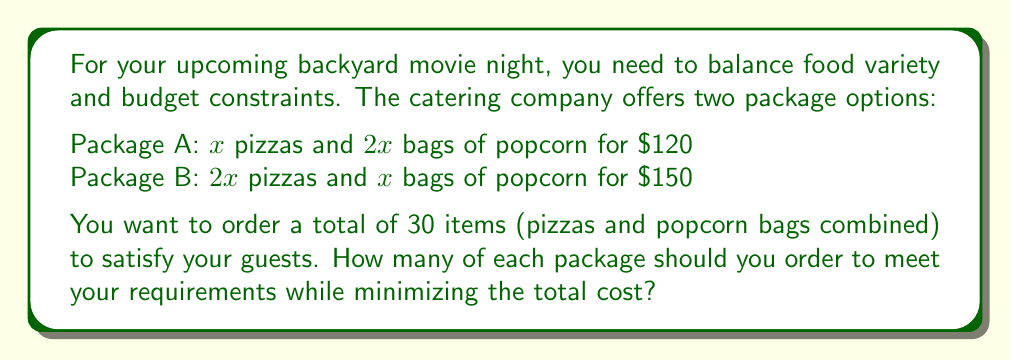Teach me how to tackle this problem. Let's solve this step-by-step using a system of equations:

1) Let $a$ be the number of Package A and $b$ be the number of Package B ordered.

2) For the total number of items:
   Package A contributes $3x$ items $(x + 2x)$
   Package B contributes $3x$ items $(2x + x)$
   So, we can write: $3a + 3b = 30$

3) Simplify: $a + b = 10$ ... (Equation 1)

4) For the total cost:
   Package A costs $\$120$
   Package B costs $\$150$
   The total cost is: $120a + 150b$

5) We want to minimize this cost subject to Equation 1.

6) We can substitute $b = 10 - a$ from Equation 1 into the cost equation:
   $\text{Cost} = 120a + 150(10 - a) = 120a + 1500 - 150a = 1500 - 30a$

7) To minimize this linear function, we should choose the maximum possible value for $a$ (since the coefficient of $a$ is negative).

8) The maximum value for $a$ is 10 (when $b = 0$), but we need both packages for variety.

9) The next best option is $a = 9$ and $b = 1$, which satisfies Equation 1.

10) Check: $9(3) + 1(3) = 30$ items, confirming our solution.
Answer: Order 9 of Package A and 1 of Package B 